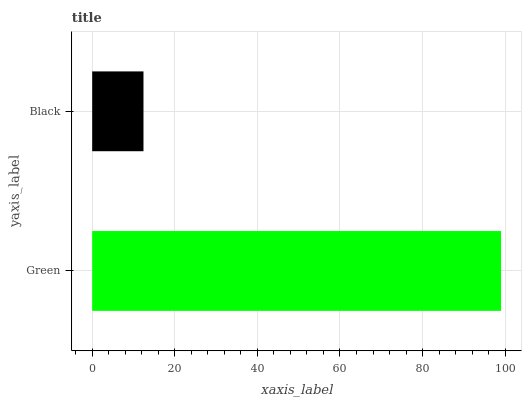Is Black the minimum?
Answer yes or no. Yes. Is Green the maximum?
Answer yes or no. Yes. Is Black the maximum?
Answer yes or no. No. Is Green greater than Black?
Answer yes or no. Yes. Is Black less than Green?
Answer yes or no. Yes. Is Black greater than Green?
Answer yes or no. No. Is Green less than Black?
Answer yes or no. No. Is Green the high median?
Answer yes or no. Yes. Is Black the low median?
Answer yes or no. Yes. Is Black the high median?
Answer yes or no. No. Is Green the low median?
Answer yes or no. No. 